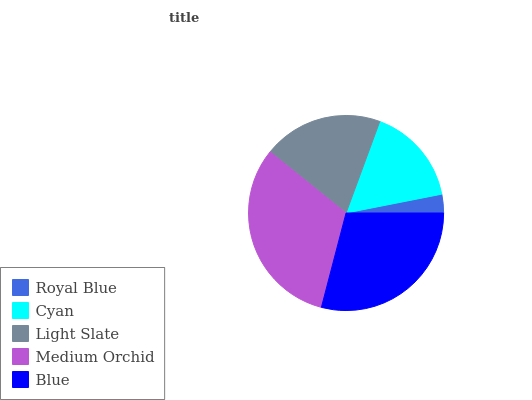Is Royal Blue the minimum?
Answer yes or no. Yes. Is Medium Orchid the maximum?
Answer yes or no. Yes. Is Cyan the minimum?
Answer yes or no. No. Is Cyan the maximum?
Answer yes or no. No. Is Cyan greater than Royal Blue?
Answer yes or no. Yes. Is Royal Blue less than Cyan?
Answer yes or no. Yes. Is Royal Blue greater than Cyan?
Answer yes or no. No. Is Cyan less than Royal Blue?
Answer yes or no. No. Is Light Slate the high median?
Answer yes or no. Yes. Is Light Slate the low median?
Answer yes or no. Yes. Is Cyan the high median?
Answer yes or no. No. Is Cyan the low median?
Answer yes or no. No. 